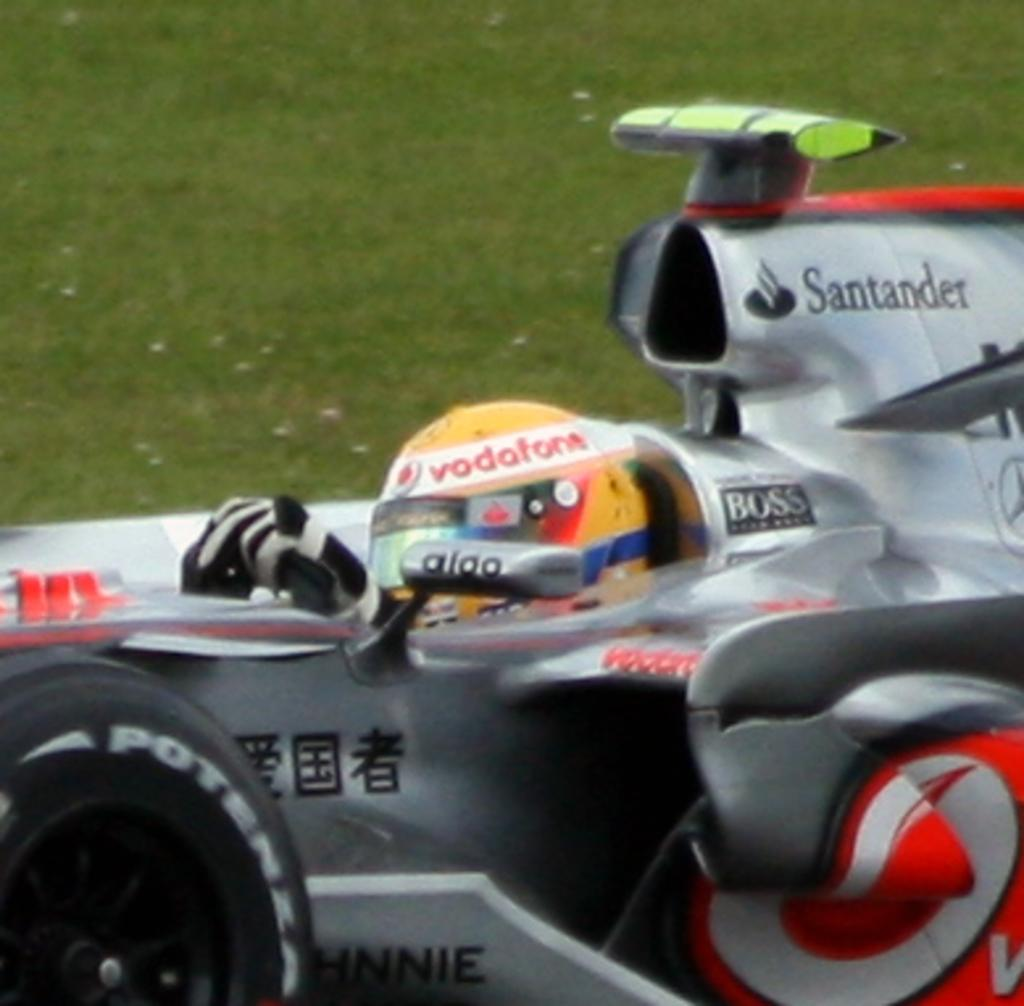<image>
Provide a brief description of the given image. A silver race car sponsored by Santander, boss and several others. 